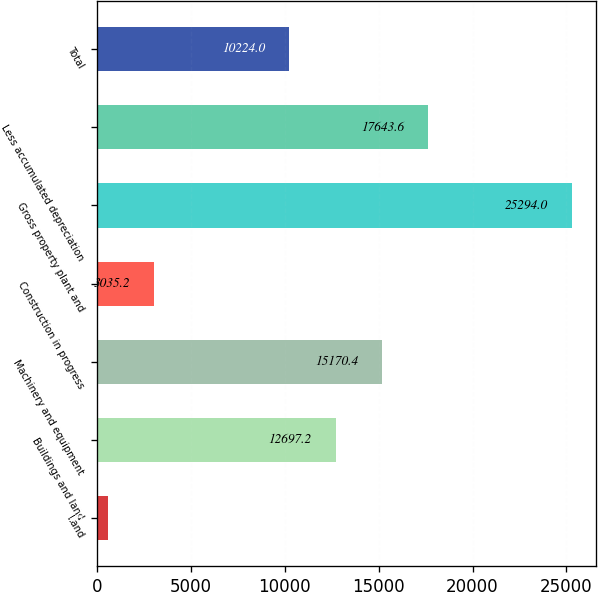<chart> <loc_0><loc_0><loc_500><loc_500><bar_chart><fcel>Land<fcel>Buildings and land<fcel>Machinery and equipment<fcel>Construction in progress<fcel>Gross property plant and<fcel>Less accumulated depreciation<fcel>Total<nl><fcel>562<fcel>12697.2<fcel>15170.4<fcel>3035.2<fcel>25294<fcel>17643.6<fcel>10224<nl></chart> 